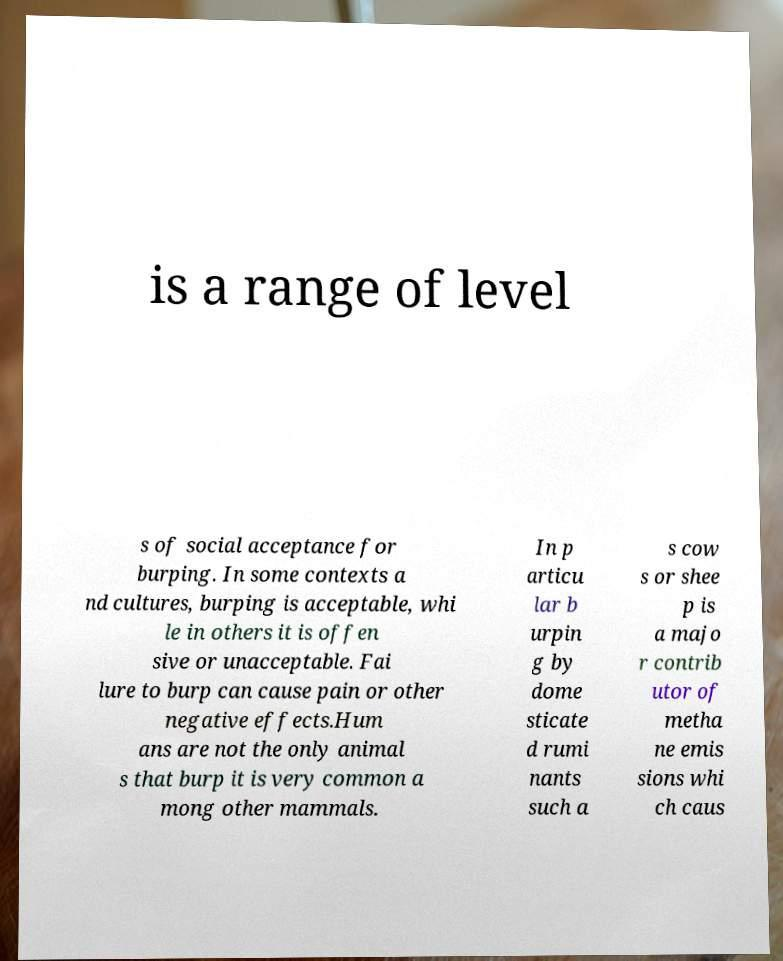Please identify and transcribe the text found in this image. is a range of level s of social acceptance for burping. In some contexts a nd cultures, burping is acceptable, whi le in others it is offen sive or unacceptable. Fai lure to burp can cause pain or other negative effects.Hum ans are not the only animal s that burp it is very common a mong other mammals. In p articu lar b urpin g by dome sticate d rumi nants such a s cow s or shee p is a majo r contrib utor of metha ne emis sions whi ch caus 